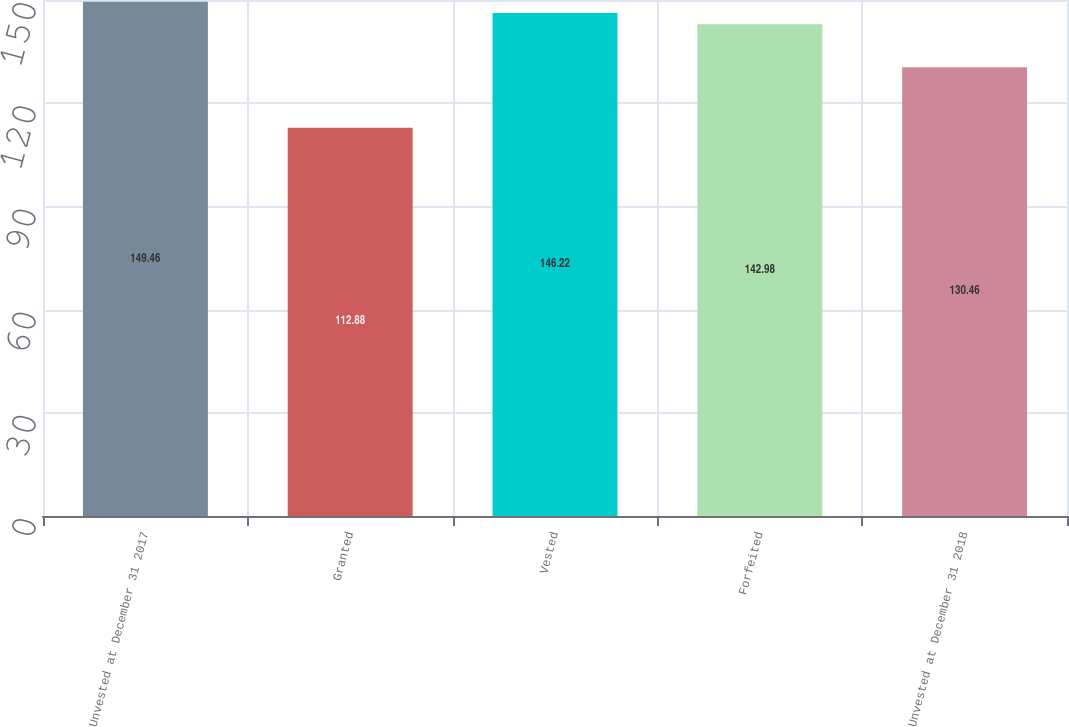Convert chart to OTSL. <chart><loc_0><loc_0><loc_500><loc_500><bar_chart><fcel>Unvested at December 31 2017<fcel>Granted<fcel>Vested<fcel>Forfeited<fcel>Unvested at December 31 2018<nl><fcel>149.46<fcel>112.88<fcel>146.22<fcel>142.98<fcel>130.46<nl></chart> 